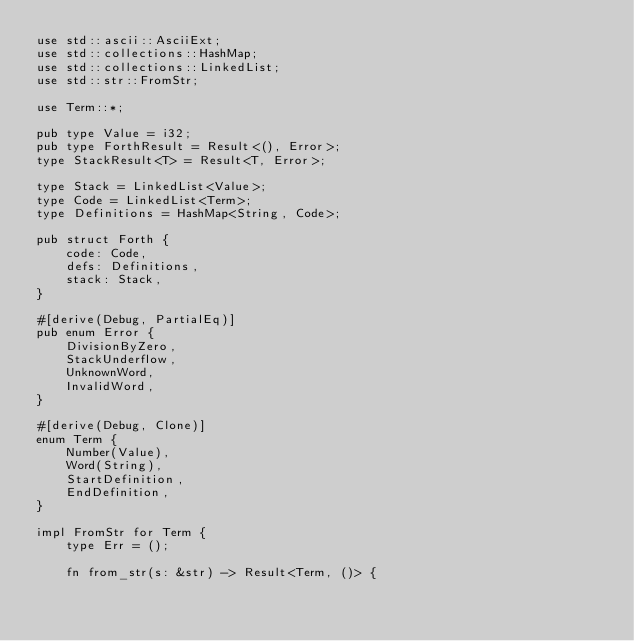<code> <loc_0><loc_0><loc_500><loc_500><_Rust_>use std::ascii::AsciiExt;
use std::collections::HashMap;
use std::collections::LinkedList;
use std::str::FromStr;

use Term::*;

pub type Value = i32;
pub type ForthResult = Result<(), Error>;
type StackResult<T> = Result<T, Error>;

type Stack = LinkedList<Value>;
type Code = LinkedList<Term>;
type Definitions = HashMap<String, Code>;

pub struct Forth {
    code: Code,
    defs: Definitions,
    stack: Stack,
}

#[derive(Debug, PartialEq)]
pub enum Error {
    DivisionByZero,
    StackUnderflow,
    UnknownWord,
    InvalidWord,
}

#[derive(Debug, Clone)]
enum Term {
    Number(Value),
    Word(String),
    StartDefinition,
    EndDefinition,
}

impl FromStr for Term {
    type Err = ();

    fn from_str(s: &str) -> Result<Term, ()> {</code> 